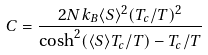<formula> <loc_0><loc_0><loc_500><loc_500>C = \frac { 2 N k _ { B } \langle S \rangle ^ { 2 } ( T _ { c } / T ) ^ { 2 } } { \cosh ^ { 2 } ( \langle S \rangle T _ { c } / T ) - T _ { c } / T }</formula> 